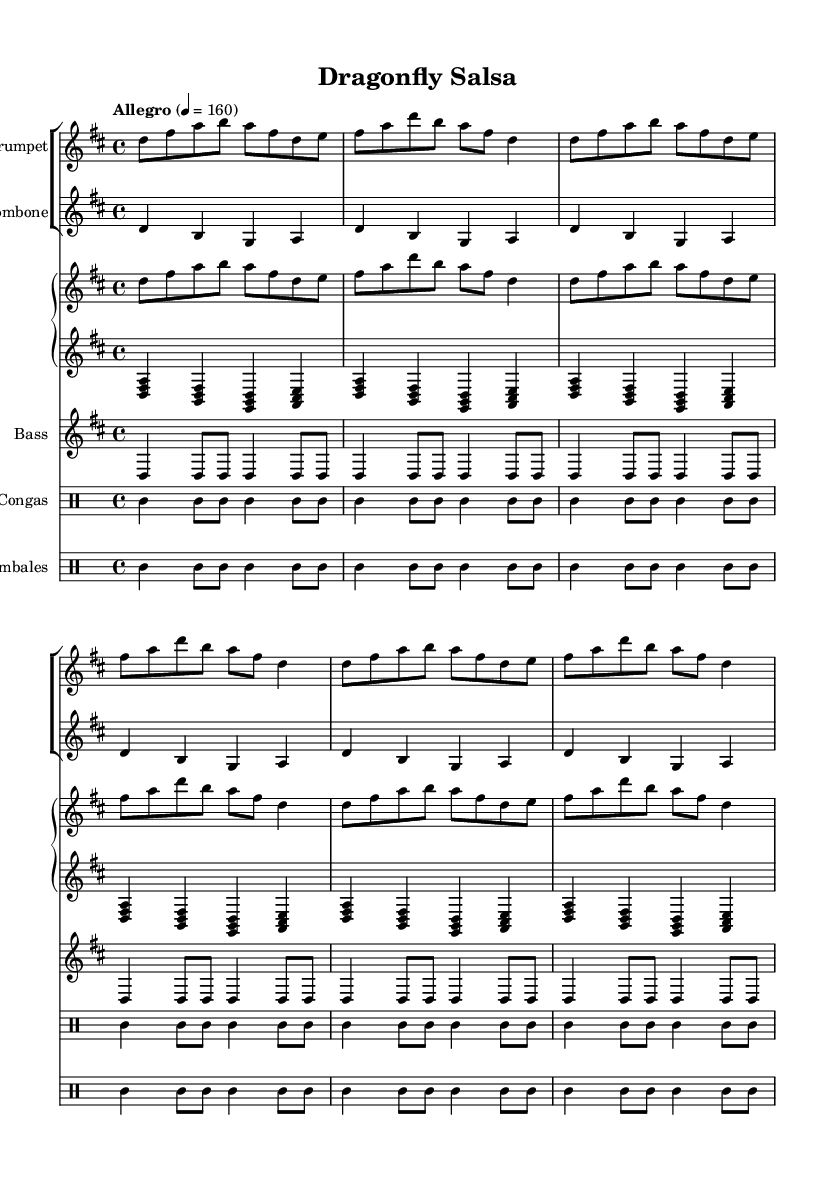What is the key signature of this music? The key signature is D major, which has two sharps: F# and C#. This can be identified at the beginning of the sheet music where the key signature is indicated.
Answer: D major What is the time signature of the piece? The time signature is 4/4, which is indicated at the start of the sheet music. This means there are four beats in each measure and a quarter note gets one beat.
Answer: 4/4 What is the tempo marking for this piece? The tempo marking is "Allegro" with a metronome marking of 160 beats per minute. This is located at the beginning section of the music and indicates a fast tempo.
Answer: Allegro, 160 How many times does the trumpet melody repeat? The trumpet melody is notated to repeat twice, which is indicated by the "repeat unfold 2" instruction. This shows that the section will be played two times in succession.
Answer: 2 What instruments are used in this composition? The composition includes trumpet, trombone, piano (with both right and left hands), bass, congas, and timbales. This can be deduced from the various staff sections labeled within the score.
Answer: Trumpet, trombone, piano, bass, congas, timbales Which instrument plays the bass line? The bass line is played by the bass instrument, which can be identified by the staff marked as "Bass" in the music sheet. The specific notes and rhythms designate this instrument's part.
Answer: Bass What type of music is "Dragonfly Salsa"? This composition is categorized as Latin salsa music, which is recognizable by its rhythm, instrumentation, and lively tempo that aligns with salsa style characteristics.
Answer: Latin salsa 